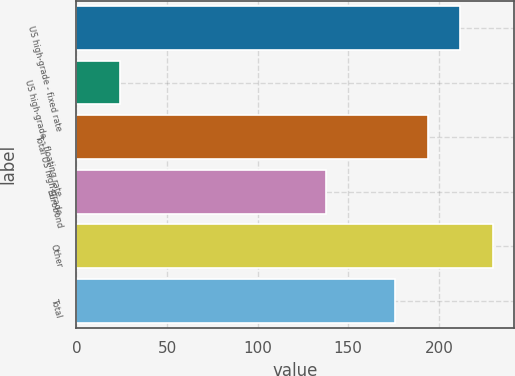Convert chart. <chart><loc_0><loc_0><loc_500><loc_500><bar_chart><fcel>US high-grade - fixed rate<fcel>US high-grade - floating rate<fcel>Total US high-grade<fcel>Eurobond<fcel>Other<fcel>Total<nl><fcel>211.8<fcel>24<fcel>193.9<fcel>138<fcel>229.7<fcel>176<nl></chart> 